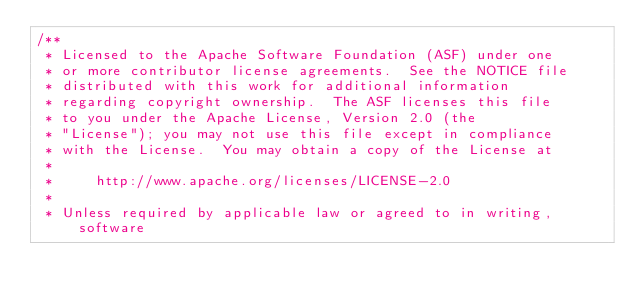<code> <loc_0><loc_0><loc_500><loc_500><_JavaScript_>/**
 * Licensed to the Apache Software Foundation (ASF) under one
 * or more contributor license agreements.  See the NOTICE file
 * distributed with this work for additional information
 * regarding copyright ownership.  The ASF licenses this file
 * to you under the Apache License, Version 2.0 (the
 * "License"); you may not use this file except in compliance
 * with the License.  You may obtain a copy of the License at
 *
 *     http://www.apache.org/licenses/LICENSE-2.0
 *
 * Unless required by applicable law or agreed to in writing, software</code> 